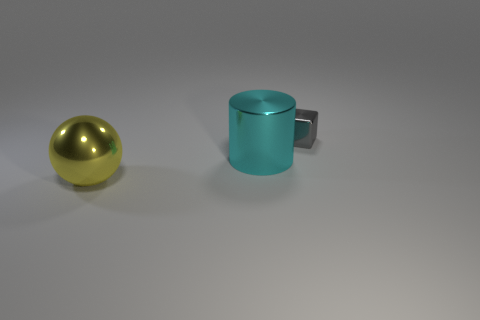Subtract all brown cubes. Subtract all cyan balls. How many cubes are left? 1 Add 3 tiny brown metal spheres. How many objects exist? 6 Subtract all gray shiny blocks. Subtract all small objects. How many objects are left? 1 Add 3 small metallic things. How many small metallic things are left? 4 Add 3 large cylinders. How many large cylinders exist? 4 Subtract 0 red spheres. How many objects are left? 3 Subtract all blocks. How many objects are left? 2 